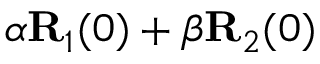Convert formula to latex. <formula><loc_0><loc_0><loc_500><loc_500>\alpha { R } _ { 1 } ( 0 ) + \beta { R } _ { 2 } ( 0 )</formula> 